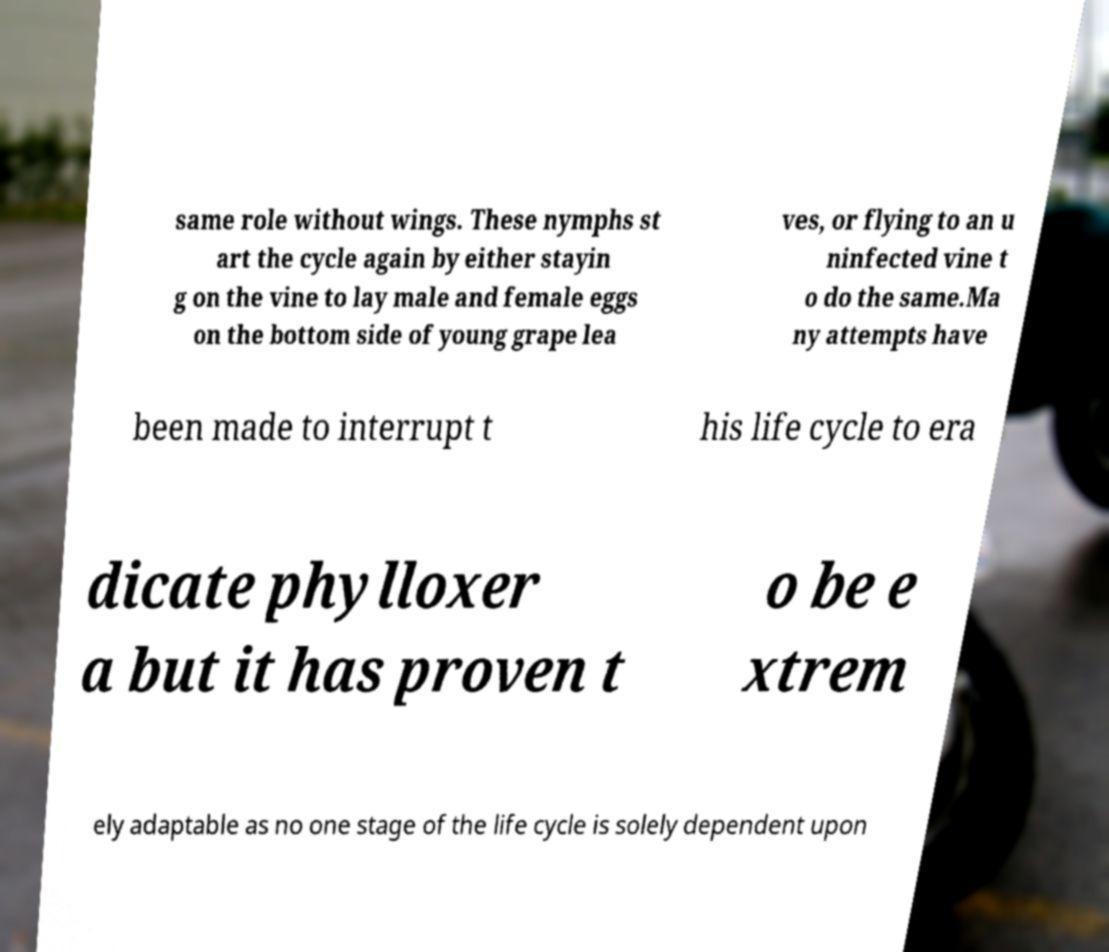There's text embedded in this image that I need extracted. Can you transcribe it verbatim? same role without wings. These nymphs st art the cycle again by either stayin g on the vine to lay male and female eggs on the bottom side of young grape lea ves, or flying to an u ninfected vine t o do the same.Ma ny attempts have been made to interrupt t his life cycle to era dicate phylloxer a but it has proven t o be e xtrem ely adaptable as no one stage of the life cycle is solely dependent upon 